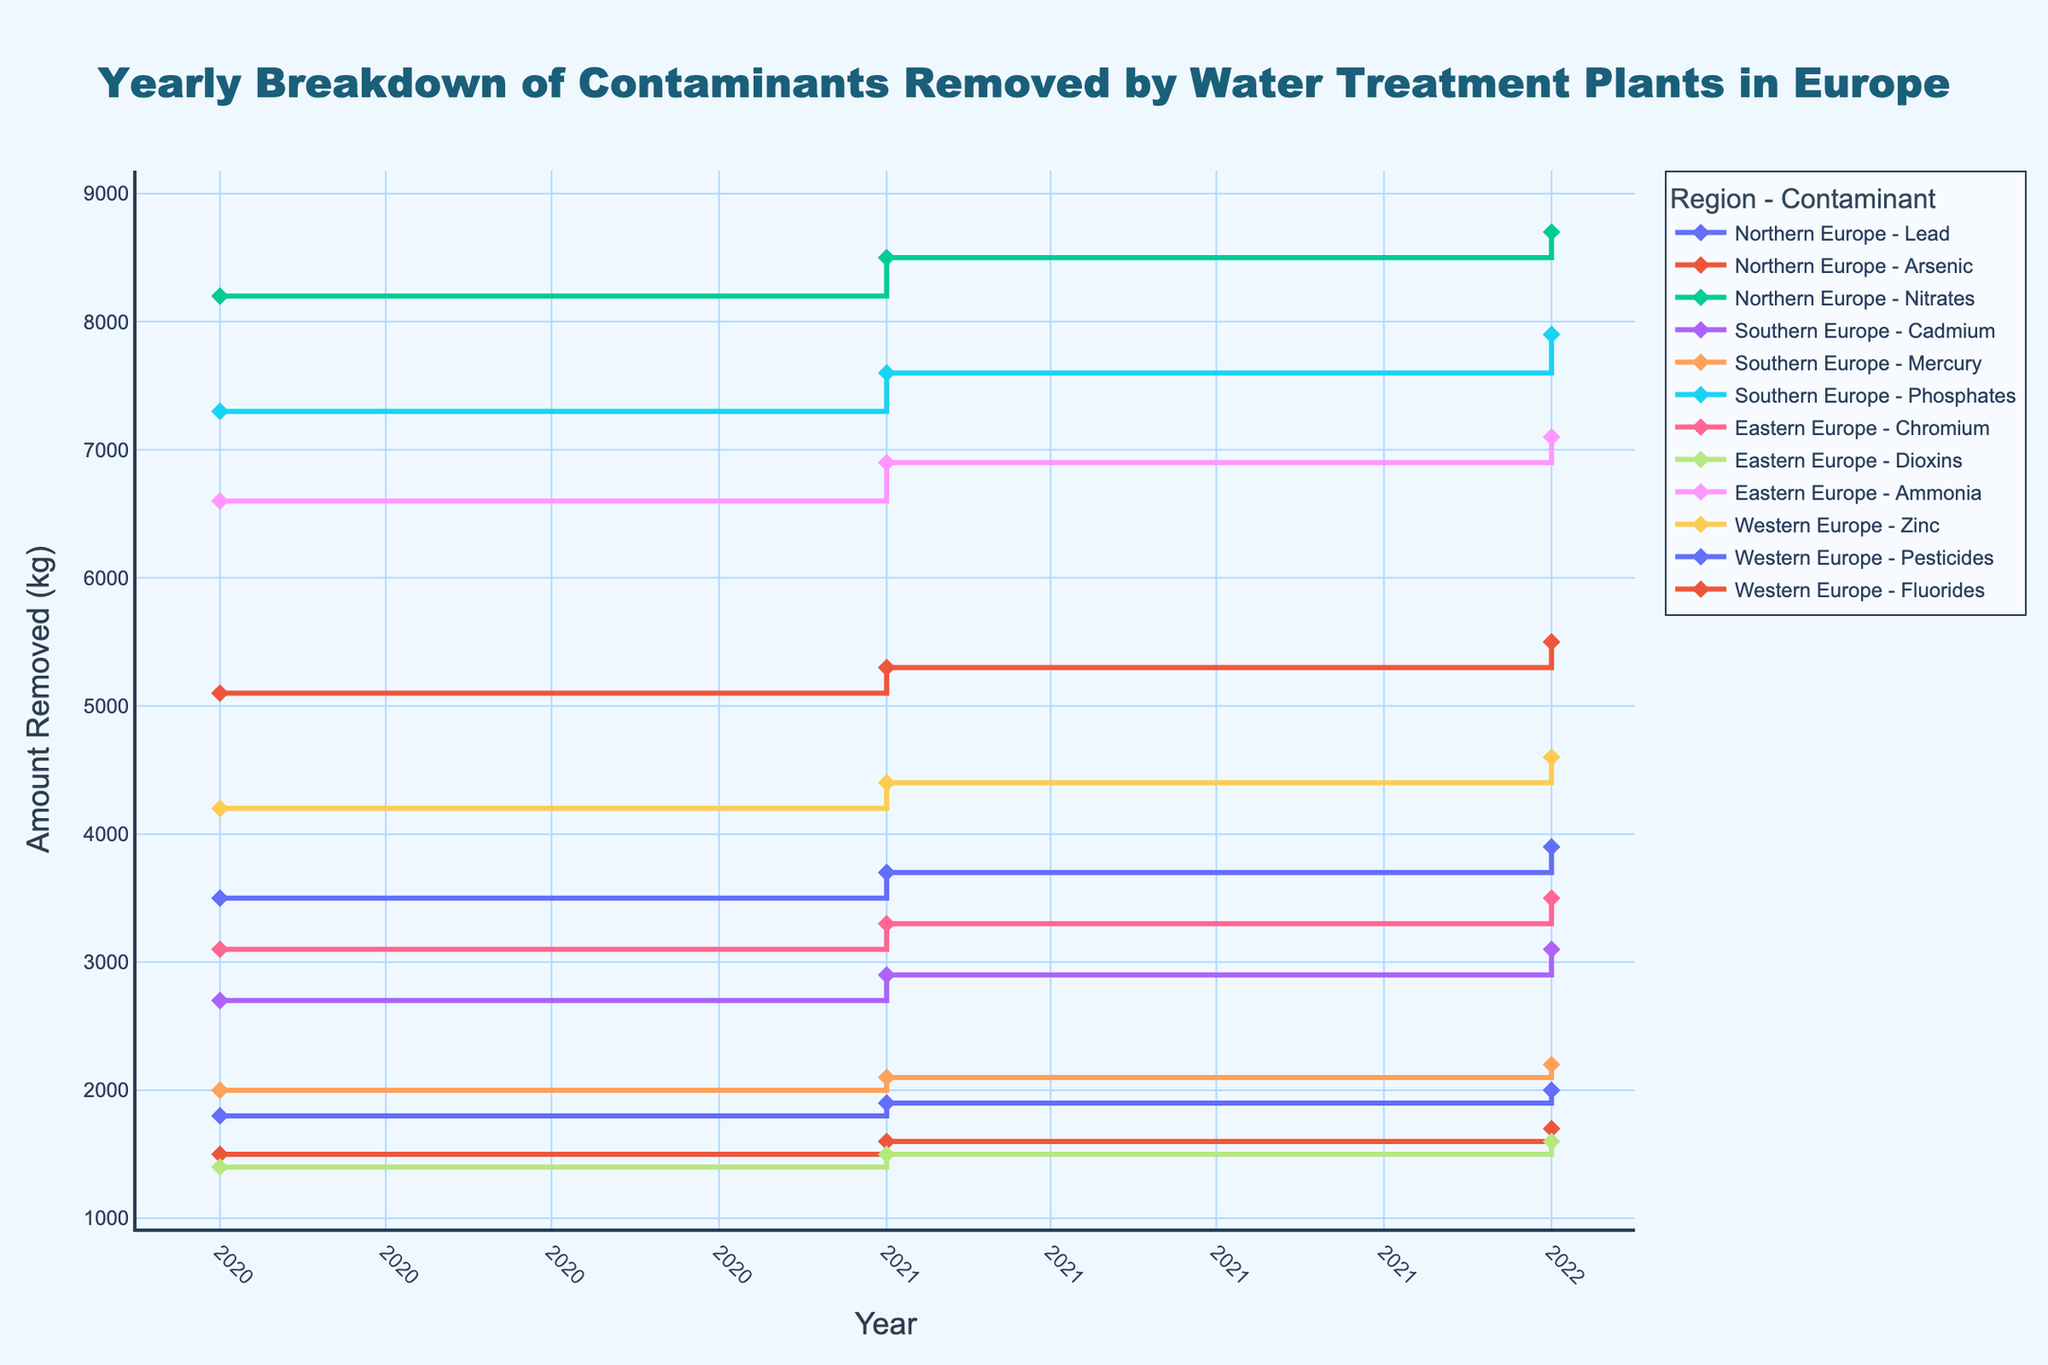How many different contaminant types are tracked in Northern Europe in 2021? The figure shows different contaminant types for each region and year. We need to look at the legend or lines/markers for Northern Europe in 2021 and count the distinct contaminant types listed.
Answer: 3 What is the total amount of Zinc removed in Western Europe from 2020 to 2022? Locate the amounts of Zinc removed in each year for Western Europe, and then sum these values. The amounts removed are 4200 kg, 4400 kg, and 4600 kg. Summing these gives 4200 + 4400 + 4600 = 13200.
Answer: 13200 kg Which region had the highest amount of contaminants removed in 2022? Compare the lines/markers for each region in 2022 and identify the highest amount. Check the y-values for all contaminant types in 2022.
Answer: Northern Europe Did the amount of Lead removed in Northern Europe increase or decrease from 2020 to 2022? Look at the trend of the line/marker for Lead in Northern Europe from 2020 to 2022. The amount increases from 3500 kg (2020) to 3700 kg (2021), and then to 3900 kg (2022).
Answer: Increase What is the average amount of Phosphates removed yearly in Southern Europe across the displayed years? Locate the amounts of Phosphates removed in Southern Europe for 2020 (7300 kg), 2021 (7600 kg), and 2022 (7900 kg). To find the average: (7300 + 7600 + 7900) / 3 = 22600 / 3 ≈ 7533.33.
Answer: 7533.33 kg How did the amount of Arsenic removed in Northern Europe change over the years? Observe the line/marker trend for Arsenic in Northern Europe from 2020 to 2022. The amounts are 1500 kg (2020), 1600 kg (2021), and 1700 kg (2022), showing a yearly increase.
Answer: Increased In which year was the smallest amount of Mercury removed in Southern Europe? Analyze the markers for Mercury in Southern Europe and find the year with the lowest y-value. The values are 2000 kg (2020), 2100 kg (2021), and 2200 kg (2022), with 2000 kg in 2020 being the smallest.
Answer: 2020 Compare the amounts of Chromium removed in Eastern Europe in 2021 and Pesticides in Western Europe in 2021. Which one is higher? Check the values of Chromium in Eastern Europe for 2021 (3300 kg) and Pesticides in Western Europe for 2021 (1900 kg). Compare 3300 kg and 1900 kg.
Answer: Chromium Is there a visible trend in the amount of Fluorides removed in Western Europe from 2020 to 2022? Analyze the line/marker for Fluorides in Western Europe. The values are 5100 kg (2020), 5300 kg (2021), and 5500 kg (2022), indicating an upward trend.
Answer: Upward trend What's the difference between the amount of Nitrates removed in Northern Europe in 2021 and the amount removed in 2022? Look at the values for Nitrates in Northern Europe for 2021 (8500 kg) and 2022 (8700 kg). The difference is 8700 - 8500 = 200 kg.
Answer: 200 kg 